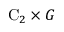Convert formula to latex. <formula><loc_0><loc_0><loc_500><loc_500>C _ { 2 } \times G</formula> 